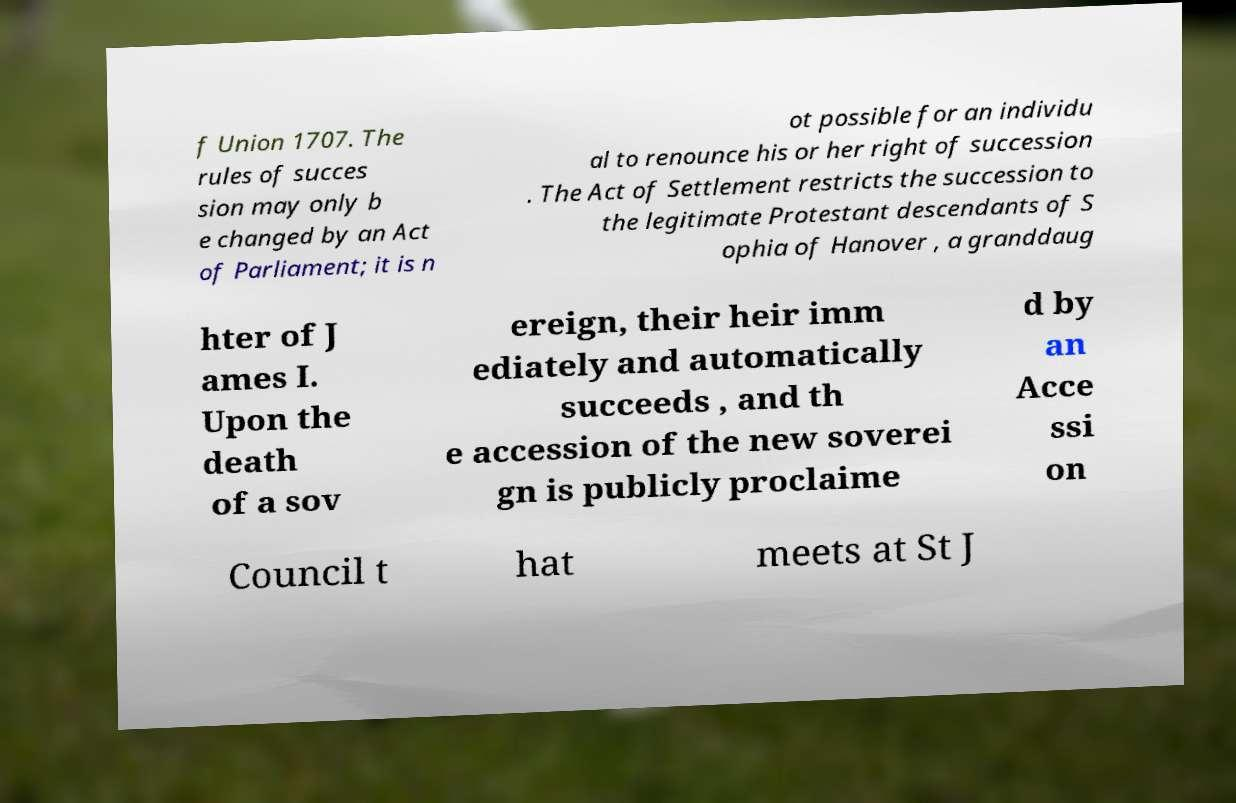Could you extract and type out the text from this image? f Union 1707. The rules of succes sion may only b e changed by an Act of Parliament; it is n ot possible for an individu al to renounce his or her right of succession . The Act of Settlement restricts the succession to the legitimate Protestant descendants of S ophia of Hanover , a granddaug hter of J ames I. Upon the death of a sov ereign, their heir imm ediately and automatically succeeds , and th e accession of the new soverei gn is publicly proclaime d by an Acce ssi on Council t hat meets at St J 